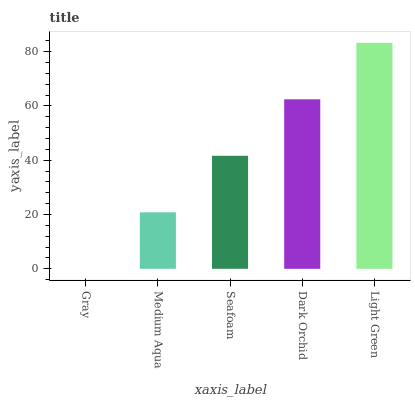Is Gray the minimum?
Answer yes or no. Yes. Is Light Green the maximum?
Answer yes or no. Yes. Is Medium Aqua the minimum?
Answer yes or no. No. Is Medium Aqua the maximum?
Answer yes or no. No. Is Medium Aqua greater than Gray?
Answer yes or no. Yes. Is Gray less than Medium Aqua?
Answer yes or no. Yes. Is Gray greater than Medium Aqua?
Answer yes or no. No. Is Medium Aqua less than Gray?
Answer yes or no. No. Is Seafoam the high median?
Answer yes or no. Yes. Is Seafoam the low median?
Answer yes or no. Yes. Is Gray the high median?
Answer yes or no. No. Is Medium Aqua the low median?
Answer yes or no. No. 